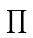Convert formula to latex. <formula><loc_0><loc_0><loc_500><loc_500>\prod</formula> 